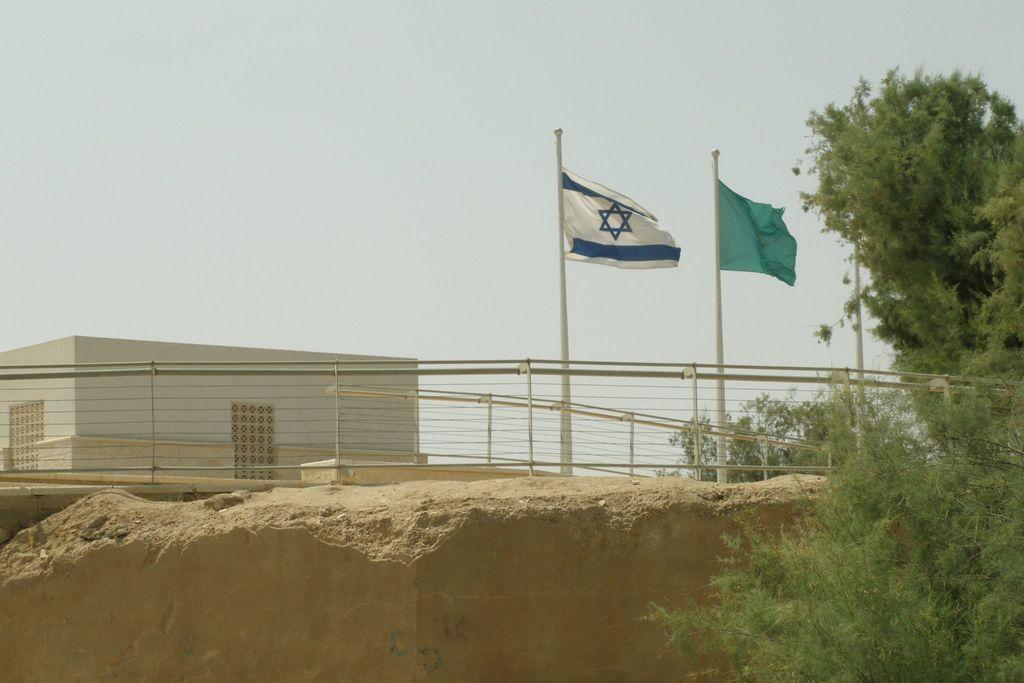Could you give a brief overview of what you see in this image? In the picture I can see flags, a building, fence, trees and some other objects. In the background I can see the sky. 